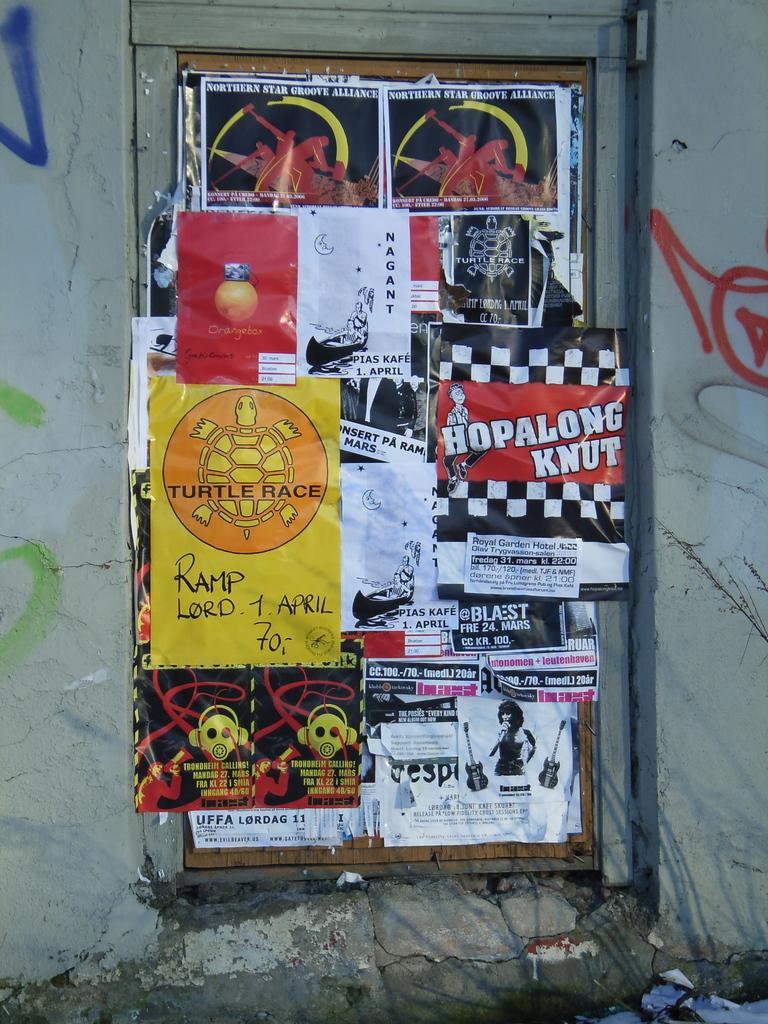What animal is referenced on this board?
Provide a short and direct response. Turtle. Whats the board about?
Provide a short and direct response. Unanswerable. 